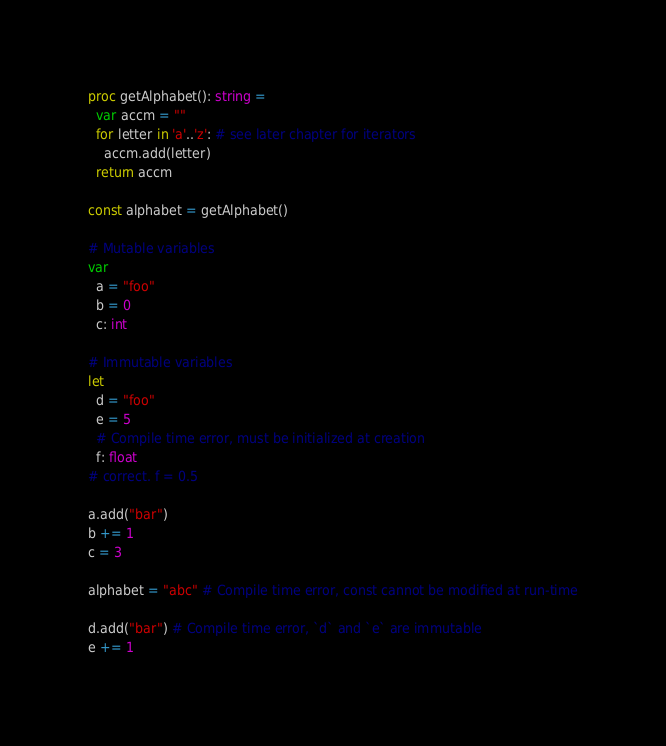Convert code to text. <code><loc_0><loc_0><loc_500><loc_500><_Nim_>proc getAlphabet(): string =
  var accm = ""
  for letter in 'a'..'z': # see later chapter for iterators
    accm.add(letter)
  return accm

const alphabet = getAlphabet()

# Mutable variables
var
  a = "foo"
  b = 0
  c: int

# Immutable variables
let
  d = "foo"
  e = 5
  # Compile time error, must be initialized at creation
  f: float
# correct. f = 0.5

a.add("bar")
b += 1
c = 3

alphabet = "abc" # Compile time error, const cannot be modified at run-time

d.add("bar") # Compile time error, `d` and `e` are immutable
e += 1

</code> 